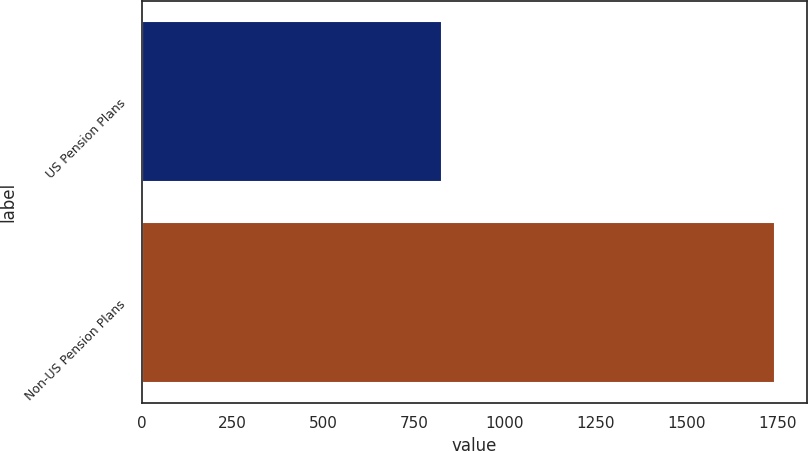Convert chart. <chart><loc_0><loc_0><loc_500><loc_500><bar_chart><fcel>US Pension Plans<fcel>Non-US Pension Plans<nl><fcel>828<fcel>1743<nl></chart> 